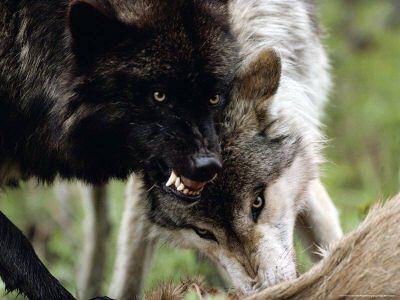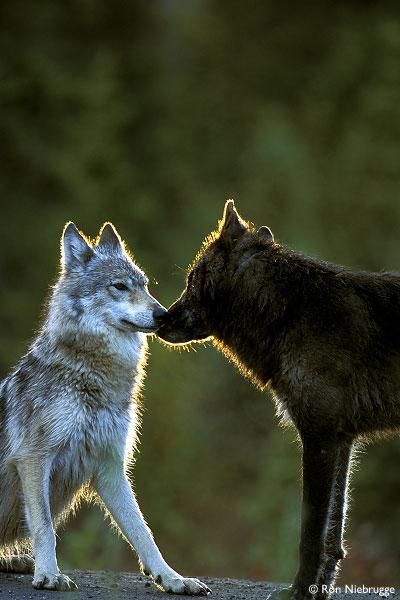The first image is the image on the left, the second image is the image on the right. Analyze the images presented: Is the assertion "At least one of the wolves is looking straight at the camera." valid? Answer yes or no. No. The first image is the image on the left, the second image is the image on the right. For the images displayed, is the sentence "The left image contains at least two wolves." factually correct? Answer yes or no. Yes. 